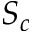Convert formula to latex. <formula><loc_0><loc_0><loc_500><loc_500>S _ { c }</formula> 